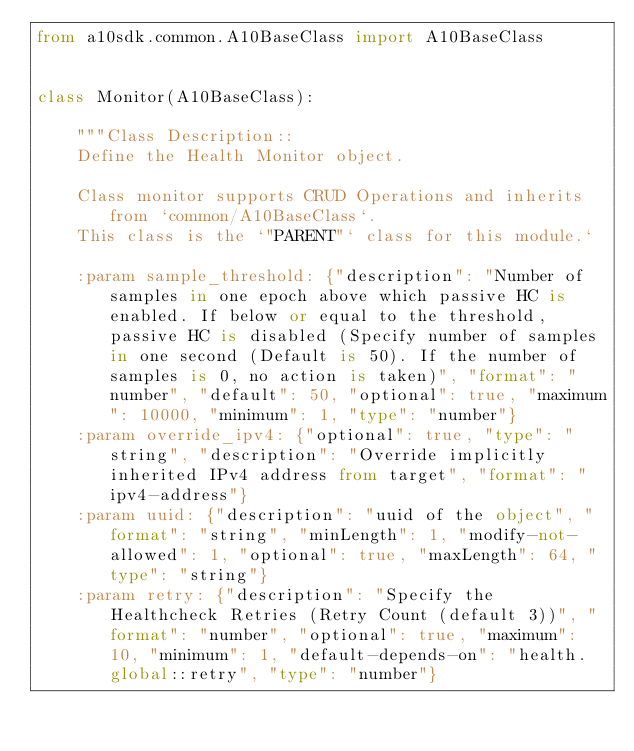Convert code to text. <code><loc_0><loc_0><loc_500><loc_500><_Python_>from a10sdk.common.A10BaseClass import A10BaseClass


class Monitor(A10BaseClass):
    
    """Class Description::
    Define the Health Monitor object.

    Class monitor supports CRUD Operations and inherits from `common/A10BaseClass`.
    This class is the `"PARENT"` class for this module.`

    :param sample_threshold: {"description": "Number of samples in one epoch above which passive HC is enabled. If below or equal to the threshold, passive HC is disabled (Specify number of samples in one second (Default is 50). If the number of samples is 0, no action is taken)", "format": "number", "default": 50, "optional": true, "maximum": 10000, "minimum": 1, "type": "number"}
    :param override_ipv4: {"optional": true, "type": "string", "description": "Override implicitly inherited IPv4 address from target", "format": "ipv4-address"}
    :param uuid: {"description": "uuid of the object", "format": "string", "minLength": 1, "modify-not-allowed": 1, "optional": true, "maxLength": 64, "type": "string"}
    :param retry: {"description": "Specify the Healthcheck Retries (Retry Count (default 3))", "format": "number", "optional": true, "maximum": 10, "minimum": 1, "default-depends-on": "health.global::retry", "type": "number"}</code> 